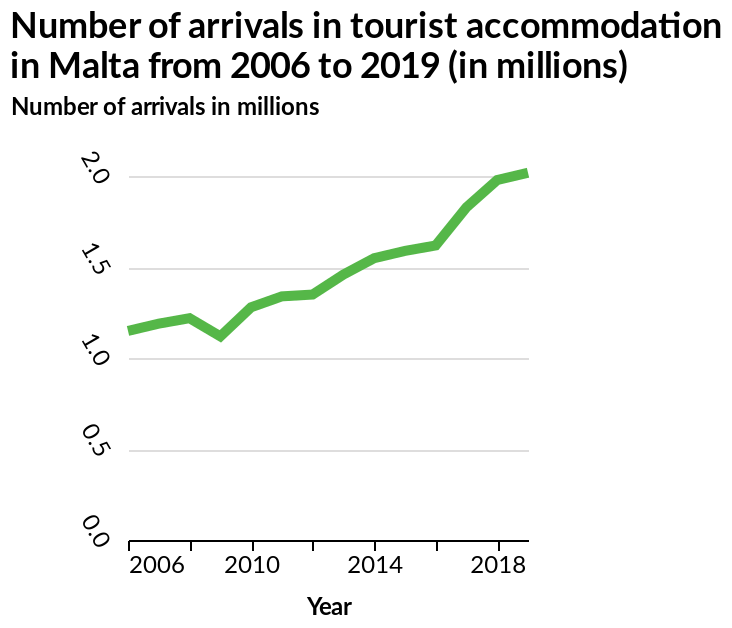<image>
please enumerates aspects of the construction of the chart This is a line chart titled Number of arrivals in tourist accommodation in Malta from 2006 to 2019 (in millions). The y-axis shows Number of arrivals in millions as linear scale from 0.0 to 2.0 while the x-axis shows Year with linear scale of range 2006 to 2018. When did tourists start to increase in Malta?  Tourists in Malta started to increase between 2006 and 2018. What does the y-axis represent? The y-axis represents the number of arrivals in millions in linear scale from 0.0 to 2.0. 